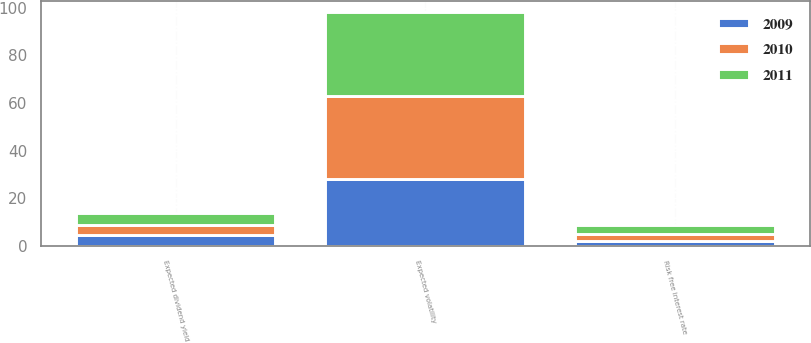Convert chart to OTSL. <chart><loc_0><loc_0><loc_500><loc_500><stacked_bar_chart><ecel><fcel>Expected volatility<fcel>Risk free interest rate<fcel>Expected dividend yield<nl><fcel>2010<fcel>35<fcel>2.9<fcel>4.4<nl><fcel>2011<fcel>35<fcel>3.6<fcel>4.9<nl><fcel>2009<fcel>28<fcel>2.3<fcel>4.6<nl></chart> 